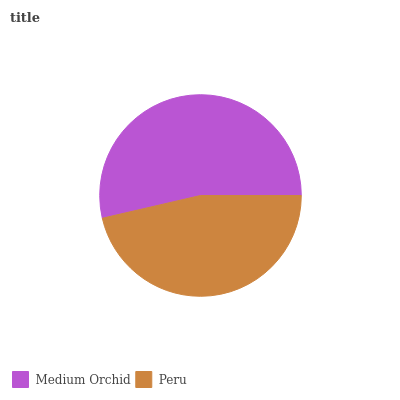Is Peru the minimum?
Answer yes or no. Yes. Is Medium Orchid the maximum?
Answer yes or no. Yes. Is Peru the maximum?
Answer yes or no. No. Is Medium Orchid greater than Peru?
Answer yes or no. Yes. Is Peru less than Medium Orchid?
Answer yes or no. Yes. Is Peru greater than Medium Orchid?
Answer yes or no. No. Is Medium Orchid less than Peru?
Answer yes or no. No. Is Medium Orchid the high median?
Answer yes or no. Yes. Is Peru the low median?
Answer yes or no. Yes. Is Peru the high median?
Answer yes or no. No. Is Medium Orchid the low median?
Answer yes or no. No. 